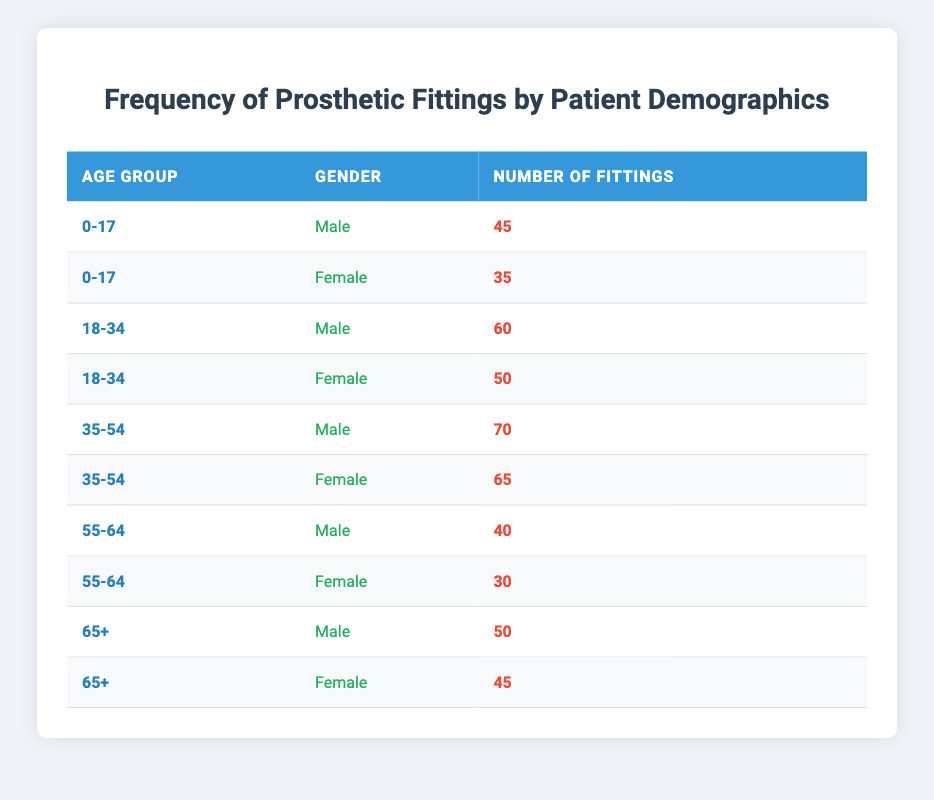What is the total number of prosthetic fittings for females in the age group 18-34? To find this, we look at the table for the age group 18-34 and note the fittings for females, which is 50. There are no other entries for females in this specific age group, so the total is simply 50.
Answer: 50 How many males received prosthetic fittings in the age group 35-54? Referring to the table, the male fittings in the age group 35-54 amount to 70. There are no other entries for males in this age group, so we take this value directly as the answer.
Answer: 70 Is the number of fittings for males in the age group 0-17 greater than the fittings for females in the same age group? From the table, males in the age group 0-17 have 45 fittings, while females in the same age group have 35 fittings. Since 45 is greater than 35, the answer is yes.
Answer: Yes What is the combined total number of prosthetic fittings for patients older than 54? We look at the table for patients aged 55-64 (40 for males and 30 for females) and for those aged 65+, (50 for males and 45 for females). So, we calculate the total: 40 + 30 + 50 + 45 = 165. Therefore, the combined total for patients older than 54 is 165.
Answer: 165 What is the average number of fittings for males across all age groups? We sum the fittings for males: (45 from 0-17) + (60 from 18-34) + (70 from 35-54) + (40 from 55-64) + (50 from 65+) = 265. There are five age groups for males, so we divide the total by 5: 265 / 5 = 53. Thus, the average number of fittings for males is 53.
Answer: 53 Are there more prosthetic fittings for females or males in the age group 55-64? In the age group 55-64, females have 30 fittings, while males have 40 fittings. Since 40 is greater than 30, the answer is that there are more fittings for males in this age group.
Answer: Males What is the difference in fittings between the oldest and youngest age groups for females? In the youngest age group (0-17), females have 35 fittings, and in the oldest age group (65+), they have 45 fittings. The difference is 45 - 35 = 10. Thus, the difference in fittings is 10.
Answer: 10 Which age group has the highest total number of fittings? First, we sum the fittings for each age group: For 0-17 (45 + 35 = 80), for 18-34 (60 + 50 = 110), for 35-54 (70 + 65 = 135), for 55-64 (40 + 30 = 70), and for 65+ (50 + 45 = 95). The highest total is in the age group 35-54, which has 135 fittings.
Answer: 35-54 